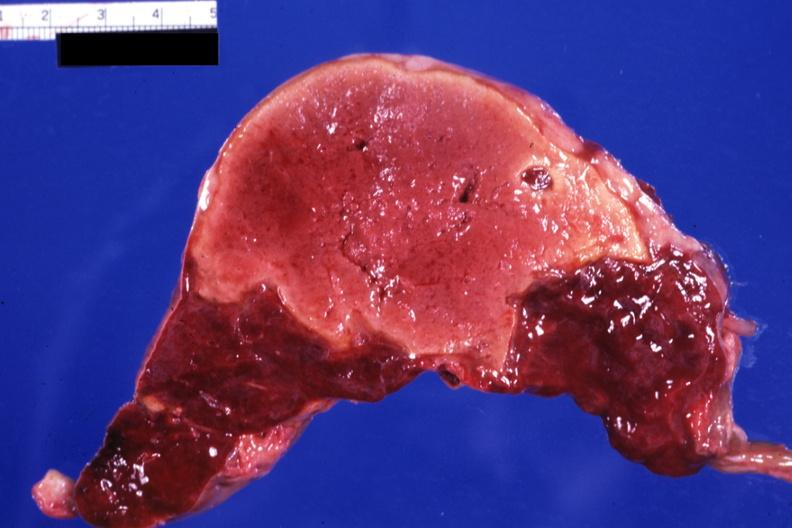s infarct present?
Answer the question using a single word or phrase. Yes 